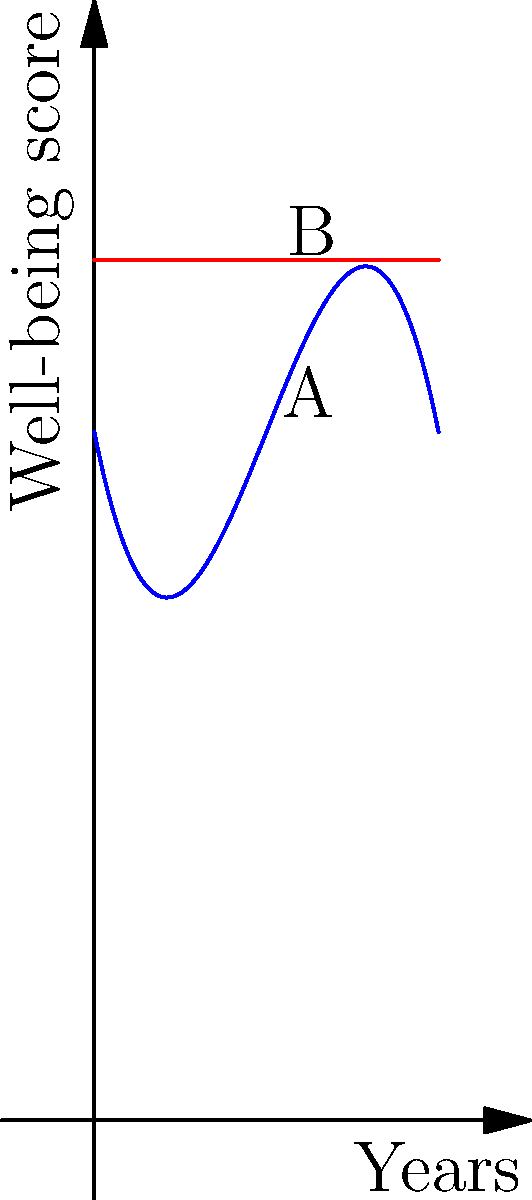The graph represents the impact of a social program on community well-being over time. The blue curve shows the well-being score as a function of years, while the red line represents the baseline well-being without intervention. The function for community well-being is given by $f(x) = -0.1x^3 + 1.5x^2 - 5x + 20$, where $x$ represents years.

a) At what point does the program's impact peak?
b) After how many years does the program's effect return to baseline?
c) What is the total positive impact (area between the curves) of the program over its lifespan? Let's approach this step-by-step:

a) To find the peak impact, we need to find the maximum of the function $f(x)$:
   1. Take the derivative: $f'(x) = -0.3x^2 + 3x - 5$
   2. Set $f'(x) = 0$ and solve:
      $-0.3x^2 + 3x - 5 = 0$
      $x = 5$ or $x = 3.33$ (approx.)
   3. The second derivative $f''(x) = -0.6x + 3$ is negative at $x = 5$, confirming it's a maximum.
   Therefore, the program's impact peaks at 5 years.

b) To find when the program returns to baseline:
   1. Set $f(x) = 25$ (baseline) and solve:
      $-0.1x^3 + 1.5x^2 - 5x + 20 = 25$
      $-0.1x^3 + 1.5x^2 - 5x - 5 = 0$
   2. This cubic equation can be solved numerically, giving $x ≈ 7.5$ years.

c) To calculate the total positive impact:
   1. We need to integrate the difference between $f(x)$ and the baseline from 0 to 7.5:
      $\int_0^{7.5} (f(x) - 25) dx$
   2. This equals:
      $\int_0^{7.5} (-0.1x^3 + 1.5x^2 - 5x - 5) dx$
   3. Evaluating this integral:
      $[-0.025x^4 + 0.5x^3 - 2.5x^2 - 5x]_0^{7.5} ≈ 23.44$

Therefore, the total positive impact is approximately 23.44 unit-years of well-being improvement.
Answer: a) 5 years
b) 7.5 years
c) 23.44 unit-years 